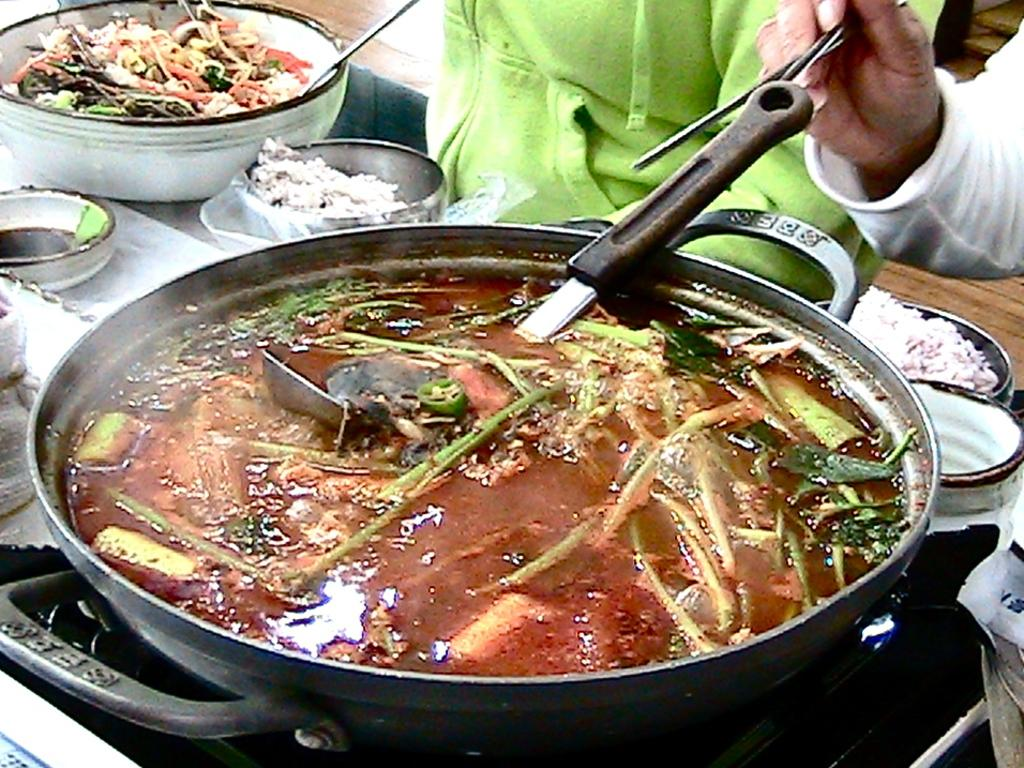What type of food is visible in the image? The food in the image is in brown and green colors. How is the food being served? The food is in a bowl. What is the person holding in the image? The person is holding sticks. Can you describe the background of the image? There are bowls on a table in the background of the image. What type of sea creature can be seen in the image? There is no sea creature present in the image. How many toes are visible in the image? There is no reference to toes in the image. 